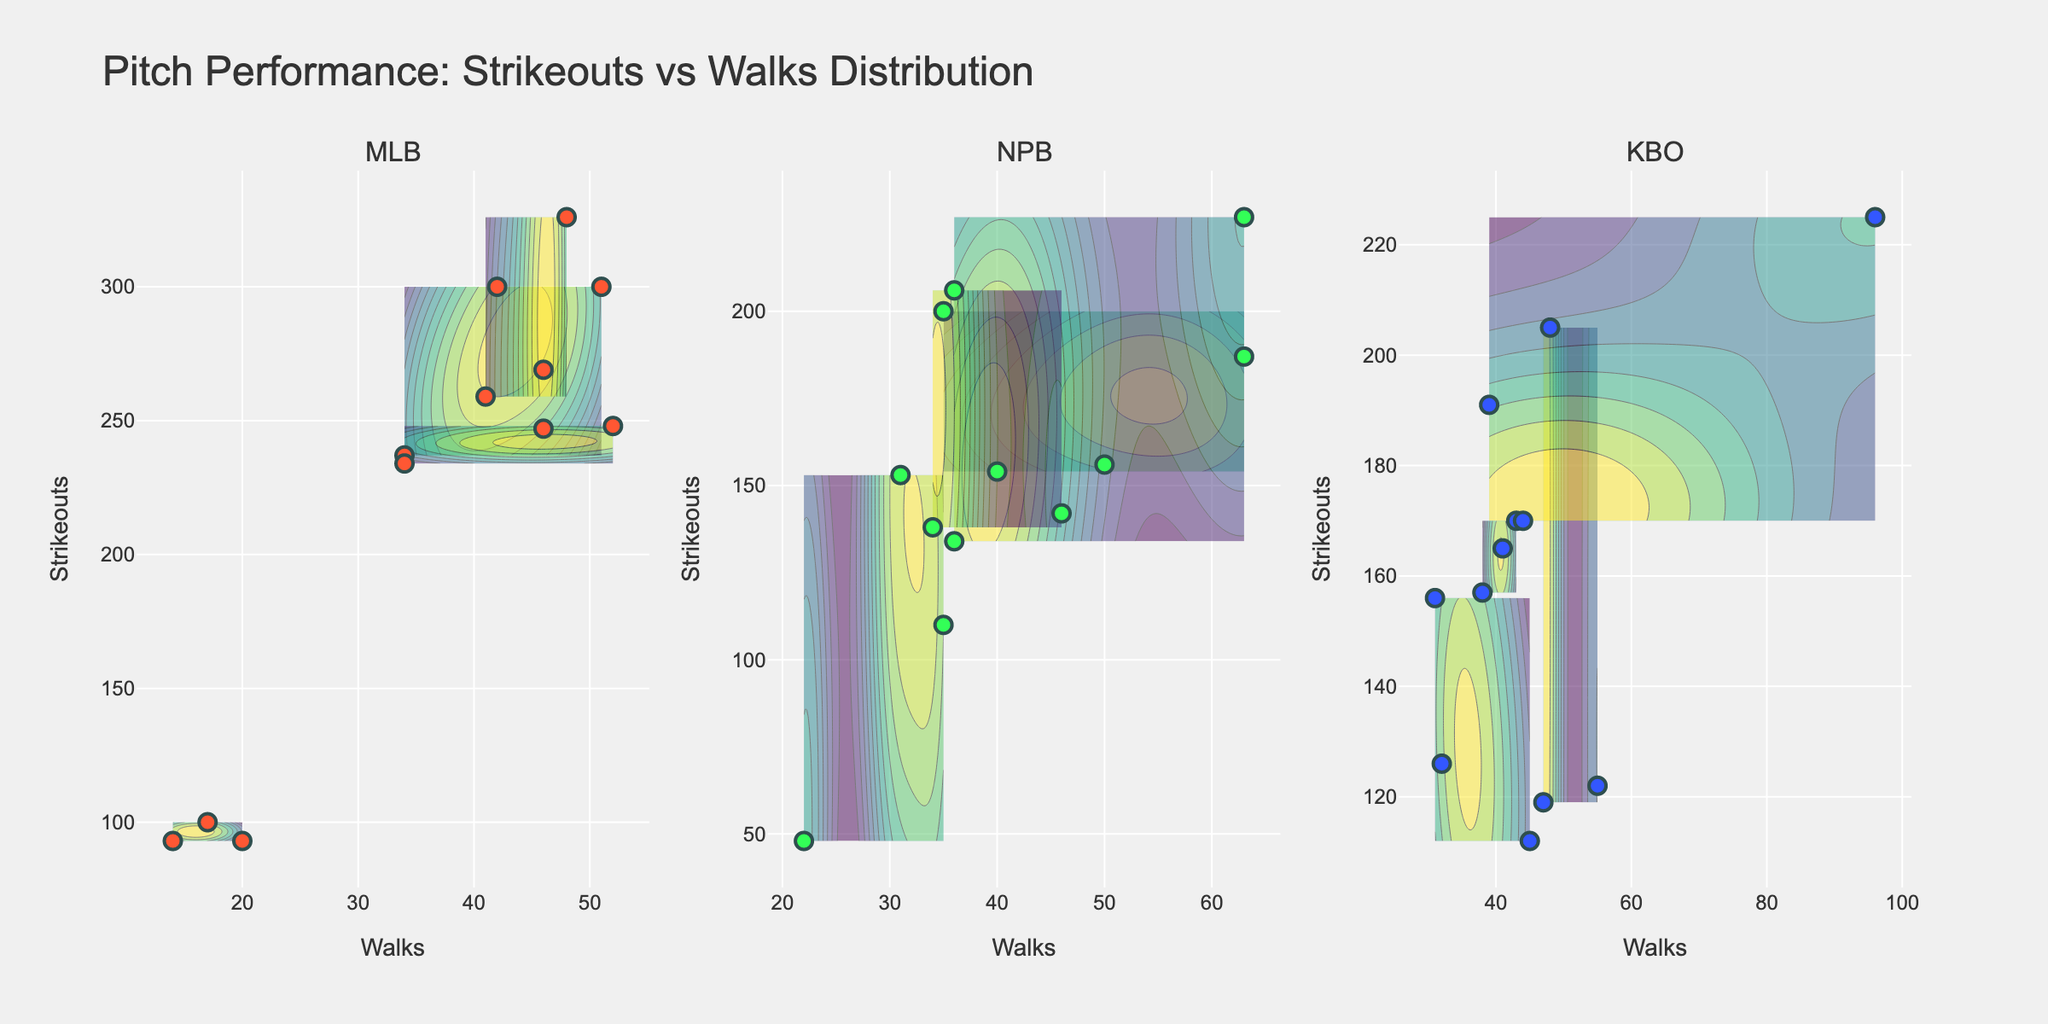What is the title of the figure? The title is usually located at the top of the figure and visually separates itself from other text elements due to larger font size or bolding. Here, the title "Pitch Performance: Strikeouts vs Walks Distribution" can be seen clearly.
Answer: Pitch Performance: Strikeouts vs Walks Distribution Which axis represents the number of walks? The axis titles are usually located at the end of each axis. In this figure, the x-axis is labeled "Walks," indicating that it represents the number of walks.
Answer: x-axis How many subplots are in the figure? Subplots are distinguishable by their individual titles or separated grid sections within the figure. There are three subplot titles, indicating that there are three subplots.
Answer: 3 Which league shows the highest density of strikeouts around 250? The contour areas with higher density will have more intense colors. In the subplot for MLB, noticeable density around 250 strikeouts can be observed.
Answer: MLB In the MLB subplot, which season stands out for having a high number of strikeouts and relatively low walks? By cross-referencing the points with the seasons and their positioning, Chris Sale in 2018 stands out, with high strikeouts and relatively low walks.
Answer: 2018 Are there any pitchers with more than 300 strikeouts in a season? If yes, name one. Looking for data points above 300 on the y-axis within the subplots can identify such pitchers. In the MLB subplot, Max Scherzer and Justin Verlander both surpassed 300 strikeouts, as shown by the y-axis.
Answer: Max Scherzer Which league has the widest variation in walks for a single season? The variation or spread can be judged by the range data points cover on the x-axis for each subplot. In the KBO subplot, during the 2021 season, the x-range is widest, indicating a significant variation in walks.
Answer: KBO Comparing the NPB and KBO leagues, which has more pitchers with strikeouts over 200 in a season? Checking the y-axis and counting the data points over the 200 mark within each subplot, NPB has more pitchers (e.g., Tomoyuki Sugano, Yoshinobu Yamamoto) over 200 strikeouts compared to KBO.
Answer: NPB For the season 2020, which league shows a more clustering of pitchers around low walks? A cluster can be identified by a concentration of overlapping data points along the x-axis. In the MLB 2020 season, data points are clustered around low walks (around 10-20).
Answer: MLB 